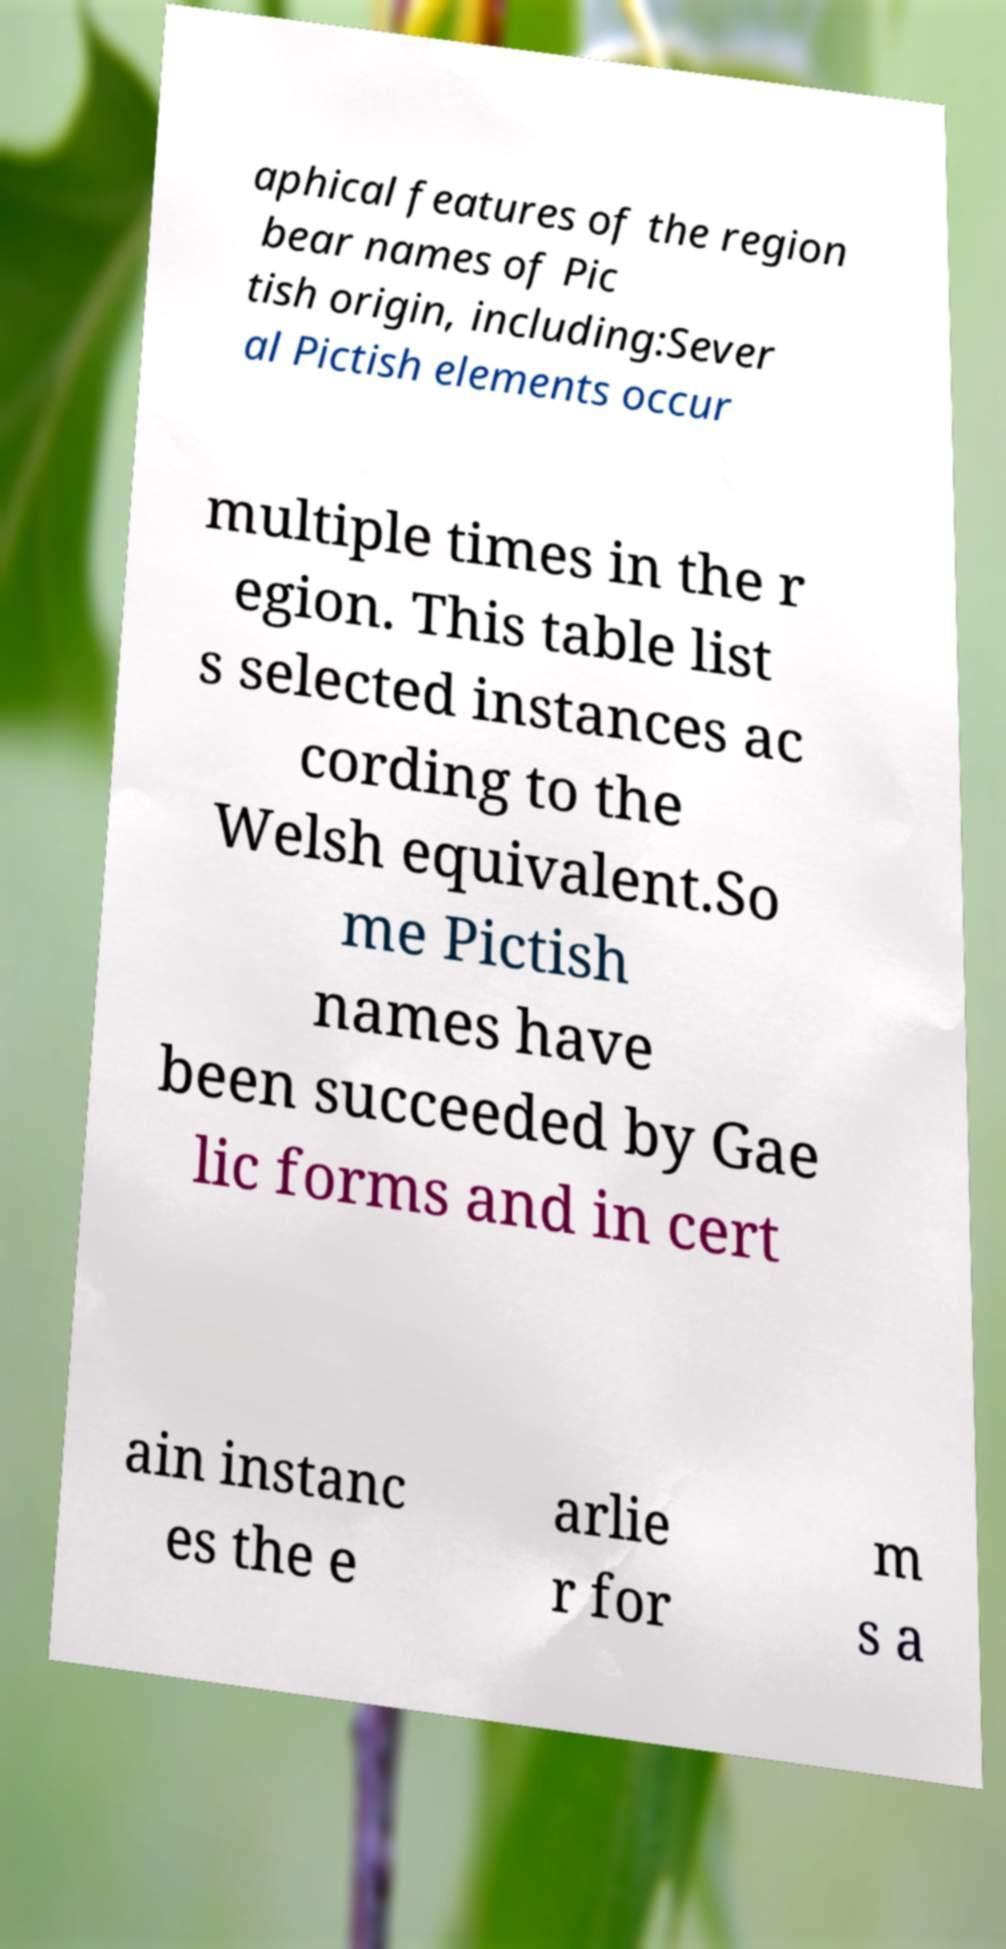For documentation purposes, I need the text within this image transcribed. Could you provide that? aphical features of the region bear names of Pic tish origin, including:Sever al Pictish elements occur multiple times in the r egion. This table list s selected instances ac cording to the Welsh equivalent.So me Pictish names have been succeeded by Gae lic forms and in cert ain instanc es the e arlie r for m s a 